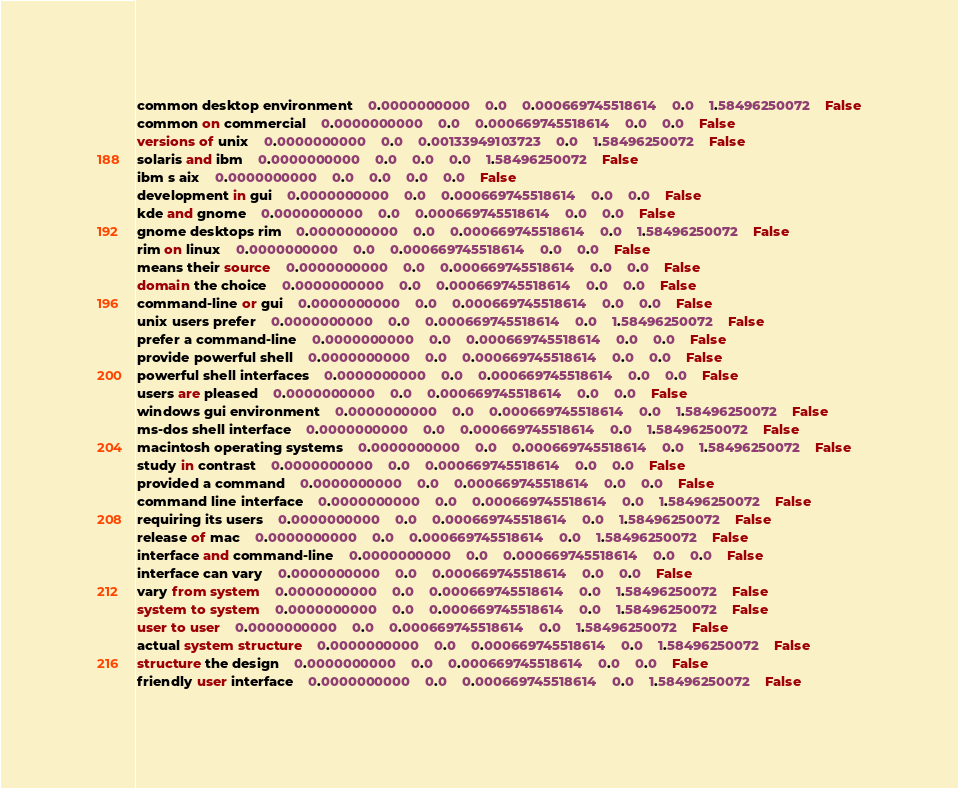<code> <loc_0><loc_0><loc_500><loc_500><_SQL_>common desktop environment	0.0000000000	0.0	0.000669745518614	0.0	1.58496250072	False
common on commercial	0.0000000000	0.0	0.000669745518614	0.0	0.0	False
versions of unix	0.0000000000	0.0	0.00133949103723	0.0	1.58496250072	False
solaris and ibm	0.0000000000	0.0	0.0	0.0	1.58496250072	False
ibm s aix	0.0000000000	0.0	0.0	0.0	0.0	False
development in gui	0.0000000000	0.0	0.000669745518614	0.0	0.0	False
kde and gnome	0.0000000000	0.0	0.000669745518614	0.0	0.0	False
gnome desktops rim	0.0000000000	0.0	0.000669745518614	0.0	1.58496250072	False
rim on linux	0.0000000000	0.0	0.000669745518614	0.0	0.0	False
means their source	0.0000000000	0.0	0.000669745518614	0.0	0.0	False
domain the choice	0.0000000000	0.0	0.000669745518614	0.0	0.0	False
command-line or gui	0.0000000000	0.0	0.000669745518614	0.0	0.0	False
unix users prefer	0.0000000000	0.0	0.000669745518614	0.0	1.58496250072	False
prefer a command-line	0.0000000000	0.0	0.000669745518614	0.0	0.0	False
provide powerful shell	0.0000000000	0.0	0.000669745518614	0.0	0.0	False
powerful shell interfaces	0.0000000000	0.0	0.000669745518614	0.0	0.0	False
users are pleased	0.0000000000	0.0	0.000669745518614	0.0	0.0	False
windows gui environment	0.0000000000	0.0	0.000669745518614	0.0	1.58496250072	False
ms-dos shell interface	0.0000000000	0.0	0.000669745518614	0.0	1.58496250072	False
macintosh operating systems	0.0000000000	0.0	0.000669745518614	0.0	1.58496250072	False
study in contrast	0.0000000000	0.0	0.000669745518614	0.0	0.0	False
provided a command	0.0000000000	0.0	0.000669745518614	0.0	0.0	False
command line interface	0.0000000000	0.0	0.000669745518614	0.0	1.58496250072	False
requiring its users	0.0000000000	0.0	0.000669745518614	0.0	1.58496250072	False
release of mac	0.0000000000	0.0	0.000669745518614	0.0	1.58496250072	False
interface and command-line	0.0000000000	0.0	0.000669745518614	0.0	0.0	False
interface can vary	0.0000000000	0.0	0.000669745518614	0.0	0.0	False
vary from system	0.0000000000	0.0	0.000669745518614	0.0	1.58496250072	False
system to system	0.0000000000	0.0	0.000669745518614	0.0	1.58496250072	False
user to user	0.0000000000	0.0	0.000669745518614	0.0	1.58496250072	False
actual system structure	0.0000000000	0.0	0.000669745518614	0.0	1.58496250072	False
structure the design	0.0000000000	0.0	0.000669745518614	0.0	0.0	False
friendly user interface	0.0000000000	0.0	0.000669745518614	0.0	1.58496250072	False</code> 